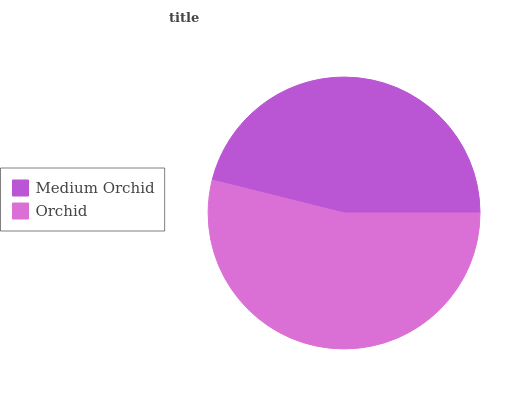Is Medium Orchid the minimum?
Answer yes or no. Yes. Is Orchid the maximum?
Answer yes or no. Yes. Is Orchid the minimum?
Answer yes or no. No. Is Orchid greater than Medium Orchid?
Answer yes or no. Yes. Is Medium Orchid less than Orchid?
Answer yes or no. Yes. Is Medium Orchid greater than Orchid?
Answer yes or no. No. Is Orchid less than Medium Orchid?
Answer yes or no. No. Is Orchid the high median?
Answer yes or no. Yes. Is Medium Orchid the low median?
Answer yes or no. Yes. Is Medium Orchid the high median?
Answer yes or no. No. Is Orchid the low median?
Answer yes or no. No. 